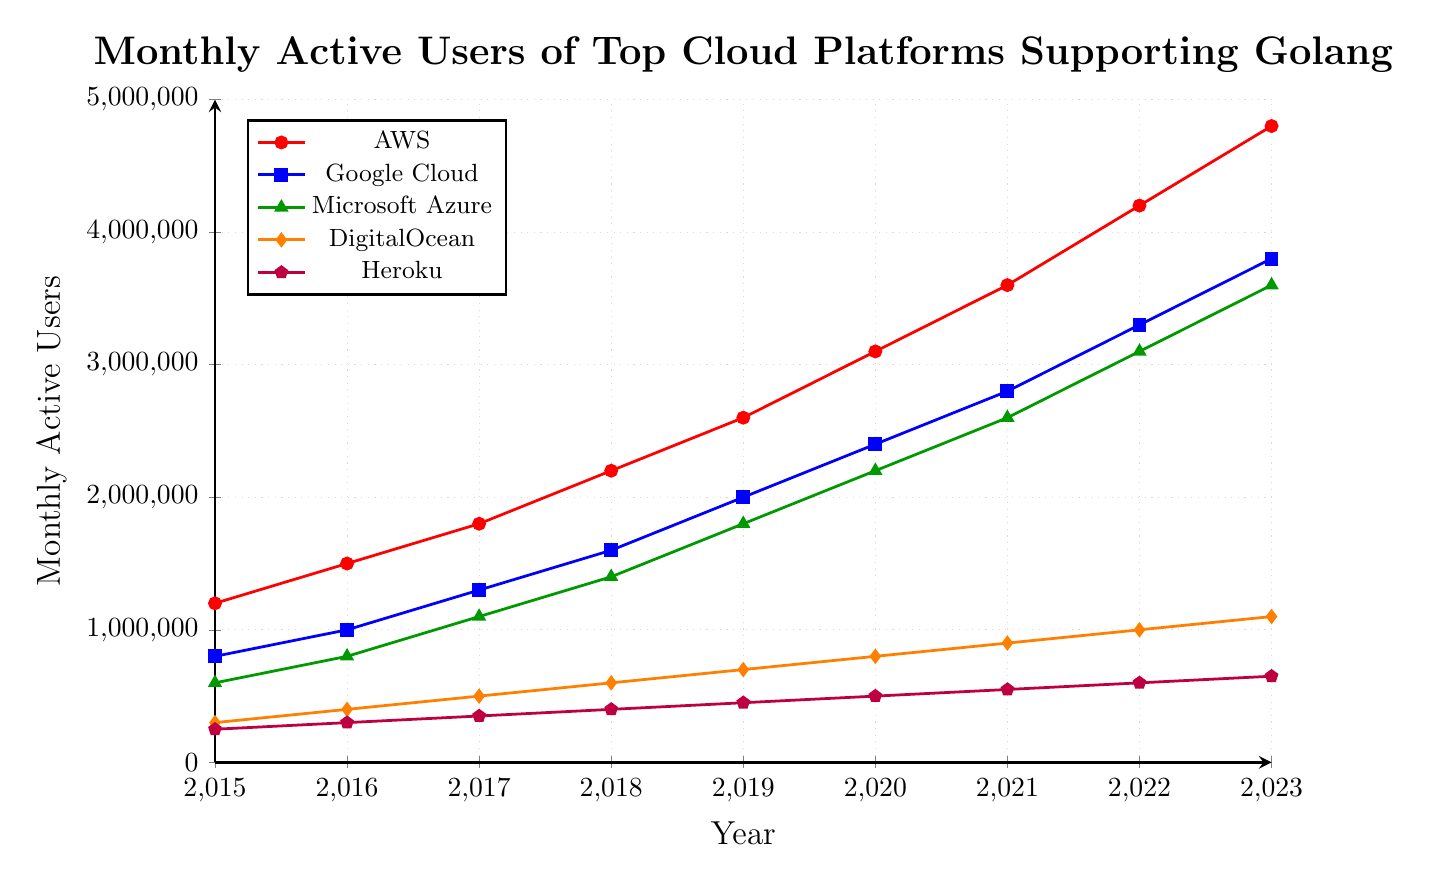What is the difference in the number of monthly active users between AWS and Google Cloud in 2023? To find the difference, subtract the number of monthly active users for Google Cloud from the number for AWS in 2023. The values are 4800000 for AWS and 3800000 for Google Cloud. So, the difference is 4800000 - 3800000 = 1000000.
Answer: 1000000 Which platform had the highest growth in monthly active users from 2015 to 2023? To determine the highest growth, calculate the difference in values from 2015 to 2023 for each platform. AWS grew from 1200000 to 4800000, which is an increase of 3600000. Google Cloud increased by 3000000, Microsoft Azure by 3000000, DigitalOcean by 800000, and Heroku by 400000. AWS had the highest growth with an increase of 3600000.
Answer: AWS What is the average number of monthly active users for Microsoft Azure from 2015 to 2023? To find the average, sum up the monthly active users for Microsoft Azure from 2015 to 2023 and then divide by the number of years. The sum is 600000 + 800000 + 1100000 + 1400000 + 1800000 + 2200000 + 2600000 + 3100000 + 3600000 = 17200000. There are 9 years, so the average is 17200000 / 9 ≈ 1911111.
Answer: 1911111 Compare the trend of monthly active users between DigitalOcean and Heroku from 2015 to 2023. Both DigitalOcean and Heroku show a steady increase in monthly active users from 2015 to 2023. DigitalOcean increases from 300000 to 1100000, while Heroku grows from 250000 to 650000. DigitalOcean had a more substantial absolute increase of 800000 compared to Heroku's 400000.
Answer: DigitalOcean had more substantial growth In which year did Google Cloud surpass 2 million monthly active users? To answer this, look at the years where Google Cloud’s monthly active users surpassed 2000000. According to the figure, Google Cloud had 2000000 active users in 2019. Therefore, it first surpassed 2000000 after 2019.
Answer: 2019 What is the combined number of monthly active users for all platforms in 2020? Sum the number of monthly active users for all platforms in 2020: AWS (3100000), Google Cloud (2400000), Microsoft Azure (2200000), DigitalOcean (800000), and Heroku (500000). The sum is 3100000 + 2400000 + 2200000 + 800000 + 500000 = 9000000.
Answer: 9000000 Which cloud platform had the smallest number of monthly active users in 2017? Look at the values for each platform in 2017. AWS had 1800000, Google Cloud had 1300000, Microsoft Azure had 1100000, DigitalOcean had 500000, and Heroku had 350000. Heroku had the smallest number with 350000.
Answer: Heroku What is the percentage increase in monthly active users for AWS from 2015 to 2023? To find the percentage increase, calculate the difference between the users in 2023 and 2015, divide by the 2015 number, and multiply by 100. For AWS, the increase is (4800000 - 1200000) / 1200000 * 100 = (3600000 / 1200000) * 100 = 300%.
Answer: 300% 